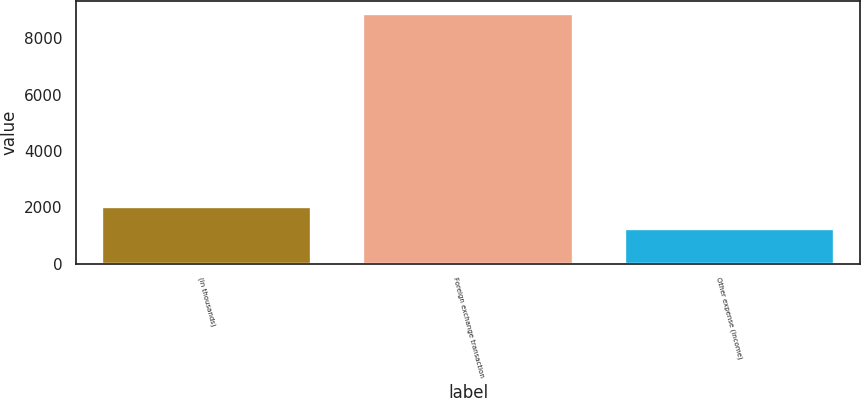<chart> <loc_0><loc_0><loc_500><loc_500><bar_chart><fcel>(in thousands)<fcel>Foreign exchange transaction<fcel>Other expense (income)<nl><fcel>2008<fcel>8881<fcel>1229<nl></chart> 